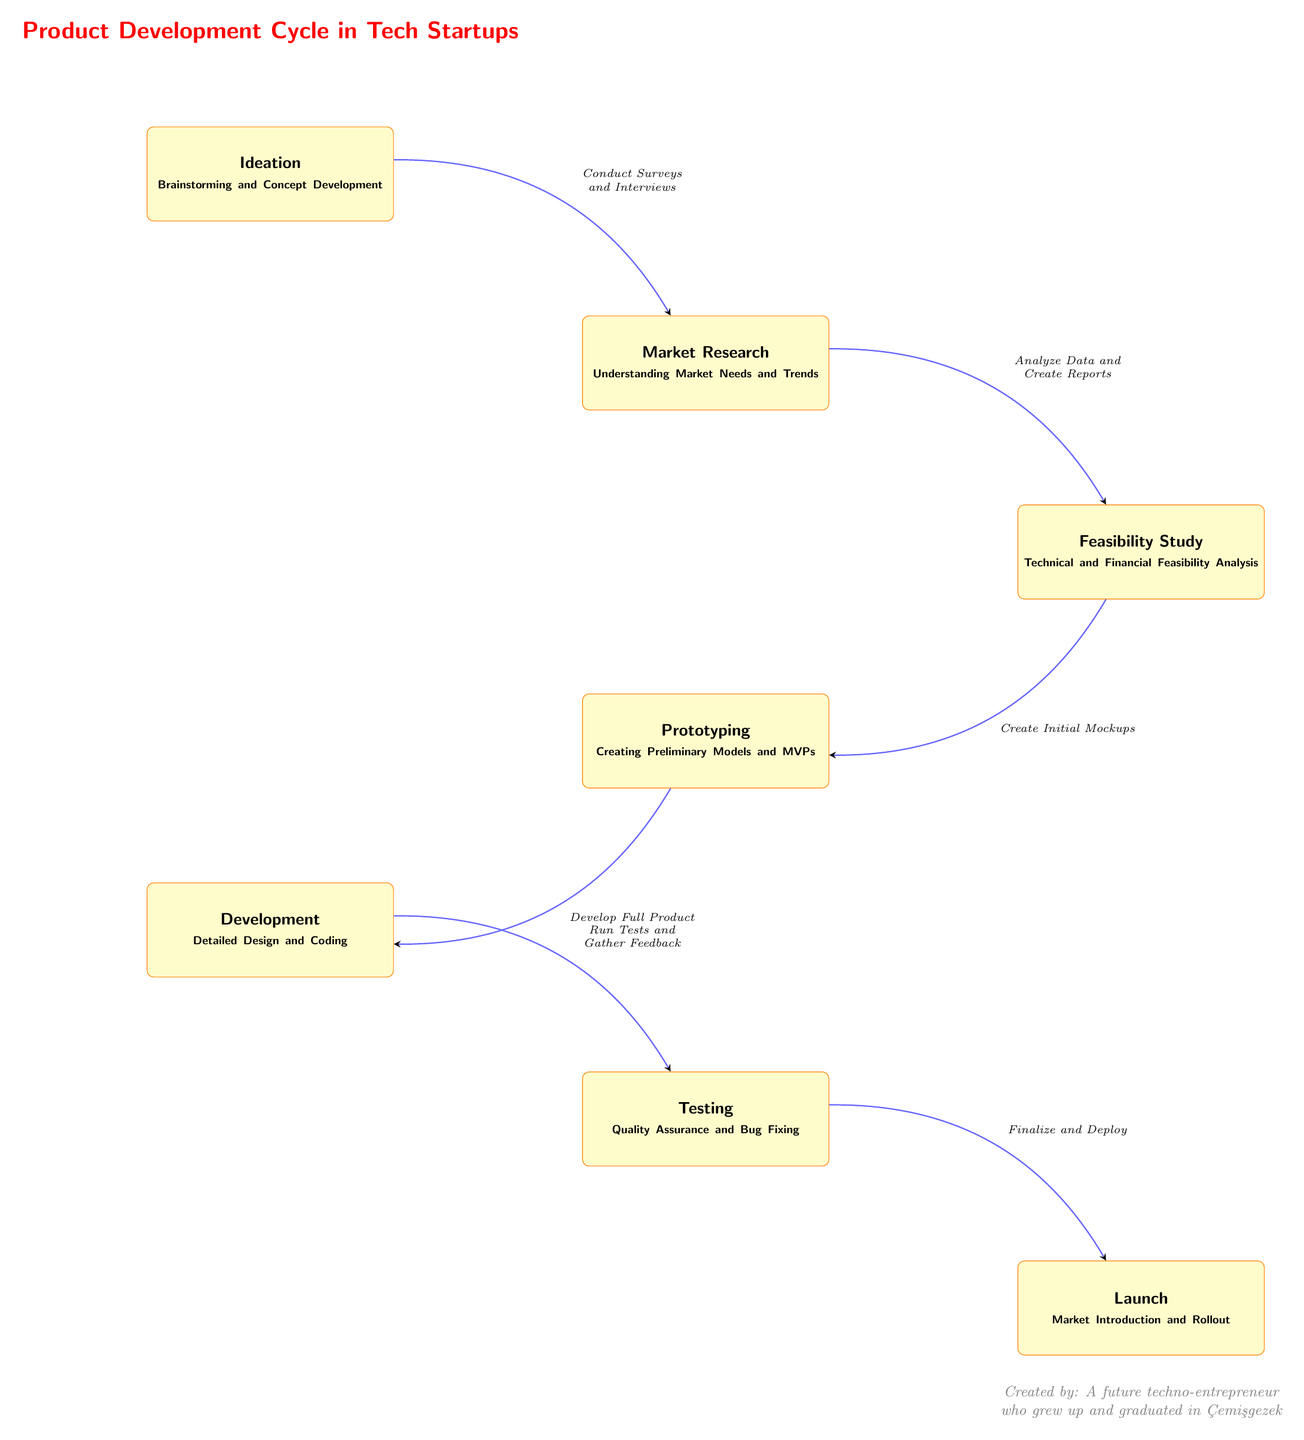What is the first step in the product development cycle? The diagram shows "Ideation" at the top, indicating that it is the first step in the product development cycle.
Answer: Ideation How many processes are outlined in the product development cycle? By counting the nodes from Ideation to Launch, there are seven distinct processes listed in the diagram.
Answer: Seven What is the output of the "Testing" phase? The arrow leading from "Testing" shows that the output leads to "Launch," suggesting that the testing phase culminates in preparing for the market introduction.
Answer: Launch Which two processes are situated diagonally opposite in the diagram? Market Research is located below right of Ideation, while Development is below left of Prototyping, making them diagonally positioned with respect to each other.
Answer: Market Research and Development What action is associated with the transition from "Feasibility Study" to "Prototyping"? The edge label indicates that the action taken while transitioning is to "Create Initial Mockups," defining the next activity in the workflow.
Answer: Create Initial Mockups Which node is preceded by "Development"? The diagram shows that "Testing" comes immediately after "Development," meaning it directly follows in the product development cycle.
Answer: Testing What type of analysis is conducted during the "Feasibility Study"? The node specifies "Technical and Financial Feasibility Analysis," identifying the focus of this phase of the development cycle.
Answer: Technical and Financial Feasibility Analysis What is the main objective of the "Market Research" phase? The purpose outlined in the node is "Understanding Market Needs and Trends," which aims to inform subsequent steps based on audience insights.
Answer: Understanding Market Needs and Trends What phase follows "Ideation" in the product development process? Following the flow of the diagram, the process that directly comes after "Ideation" is "Market Research."
Answer: Market Research 